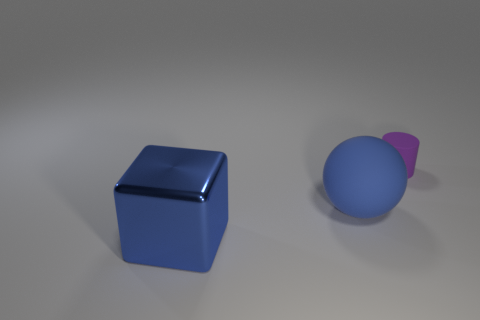Add 3 rubber objects. How many objects exist? 6 Subtract all cylinders. How many objects are left? 2 Subtract all large blocks. Subtract all blue matte cubes. How many objects are left? 2 Add 1 small purple matte cylinders. How many small purple matte cylinders are left? 2 Add 2 shiny objects. How many shiny objects exist? 3 Subtract 0 cyan cubes. How many objects are left? 3 